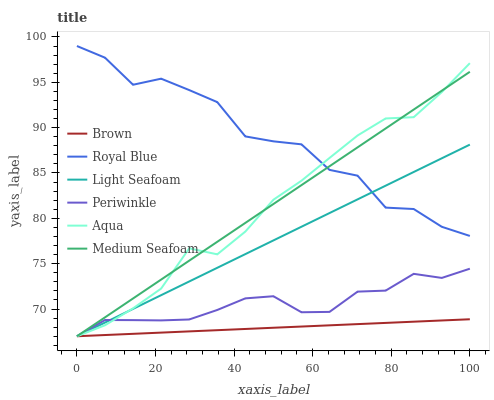Does Brown have the minimum area under the curve?
Answer yes or no. Yes. Does Royal Blue have the maximum area under the curve?
Answer yes or no. Yes. Does Aqua have the minimum area under the curve?
Answer yes or no. No. Does Aqua have the maximum area under the curve?
Answer yes or no. No. Is Light Seafoam the smoothest?
Answer yes or no. Yes. Is Royal Blue the roughest?
Answer yes or no. Yes. Is Aqua the smoothest?
Answer yes or no. No. Is Aqua the roughest?
Answer yes or no. No. Does Brown have the lowest value?
Answer yes or no. Yes. Does Royal Blue have the lowest value?
Answer yes or no. No. Does Royal Blue have the highest value?
Answer yes or no. Yes. Does Aqua have the highest value?
Answer yes or no. No. Is Brown less than Royal Blue?
Answer yes or no. Yes. Is Royal Blue greater than Periwinkle?
Answer yes or no. Yes. Does Light Seafoam intersect Brown?
Answer yes or no. Yes. Is Light Seafoam less than Brown?
Answer yes or no. No. Is Light Seafoam greater than Brown?
Answer yes or no. No. Does Brown intersect Royal Blue?
Answer yes or no. No. 